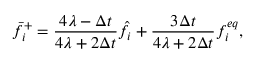<formula> <loc_0><loc_0><loc_500><loc_500>\bar { f } _ { i } ^ { + } = \frac { 4 \lambda - \Delta t } { 4 \lambda + 2 \Delta t } \hat { f } _ { i } + \frac { 3 \Delta t } { 4 \lambda + 2 \Delta t } f _ { i } ^ { e q } ,</formula> 